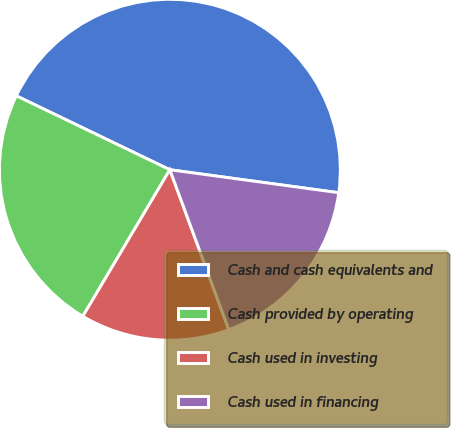<chart> <loc_0><loc_0><loc_500><loc_500><pie_chart><fcel>Cash and cash equivalents and<fcel>Cash provided by operating<fcel>Cash used in investing<fcel>Cash used in financing<nl><fcel>45.01%<fcel>23.61%<fcel>14.15%<fcel>17.23%<nl></chart> 